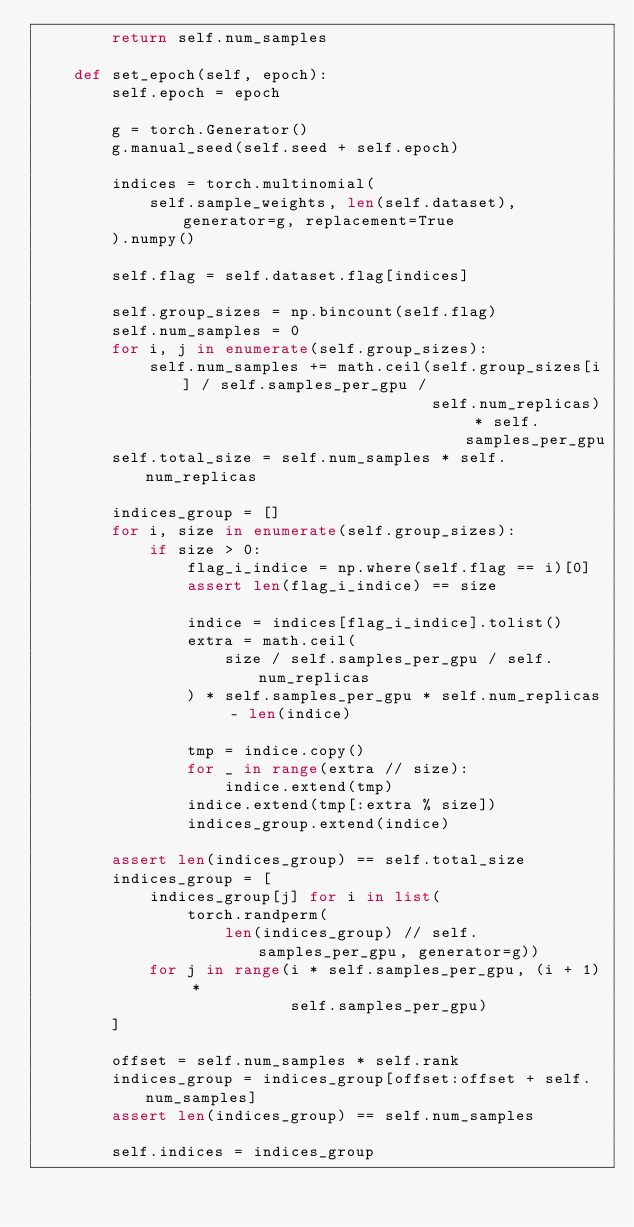Convert code to text. <code><loc_0><loc_0><loc_500><loc_500><_Python_>        return self.num_samples        

    def set_epoch(self, epoch):
        self.epoch = epoch

        g = torch.Generator()
        g.manual_seed(self.seed + self.epoch)

        indices = torch.multinomial(
            self.sample_weights, len(self.dataset), generator=g, replacement=True
        ).numpy()

        self.flag = self.dataset.flag[indices]

        self.group_sizes = np.bincount(self.flag)
        self.num_samples = 0
        for i, j in enumerate(self.group_sizes):
            self.num_samples += math.ceil(self.group_sizes[i] / self.samples_per_gpu / 
                                          self.num_replicas) * self.samples_per_gpu
        self.total_size = self.num_samples * self.num_replicas

        indices_group = []
        for i, size in enumerate(self.group_sizes):
            if size > 0:
                flag_i_indice = np.where(self.flag == i)[0]
                assert len(flag_i_indice) == size

                indice = indices[flag_i_indice].tolist()
                extra = math.ceil(
                    size / self.samples_per_gpu / self.num_replicas
                ) * self.samples_per_gpu * self.num_replicas - len(indice)

                tmp = indice.copy()
                for _ in range(extra // size):
                    indice.extend(tmp)
                indice.extend(tmp[:extra % size])
                indices_group.extend(indice)

        assert len(indices_group) == self.total_size
        indices_group = [
            indices_group[j] for i in list(
                torch.randperm(
                    len(indices_group) // self.samples_per_gpu, generator=g))
            for j in range(i * self.samples_per_gpu, (i + 1) *
                           self.samples_per_gpu)
        ]

        offset = self.num_samples * self.rank
        indices_group = indices_group[offset:offset + self.num_samples]
        assert len(indices_group) == self.num_samples

        self.indices = indices_group


</code> 